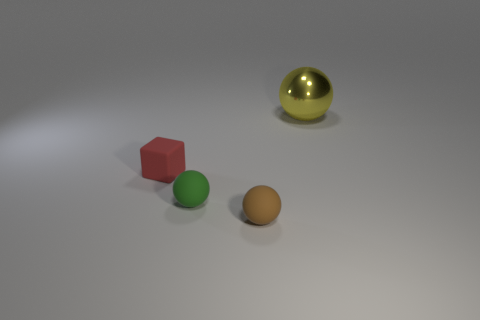Subtract all tiny spheres. How many spheres are left? 1 Add 2 green matte spheres. How many objects exist? 6 Subtract all blocks. How many objects are left? 3 Subtract all brown spheres. How many spheres are left? 2 Subtract 1 spheres. How many spheres are left? 2 Subtract all gray matte cubes. Subtract all red rubber blocks. How many objects are left? 3 Add 1 metallic balls. How many metallic balls are left? 2 Add 1 metal things. How many metal things exist? 2 Subtract 0 gray cubes. How many objects are left? 4 Subtract all yellow cubes. Subtract all purple cylinders. How many cubes are left? 1 